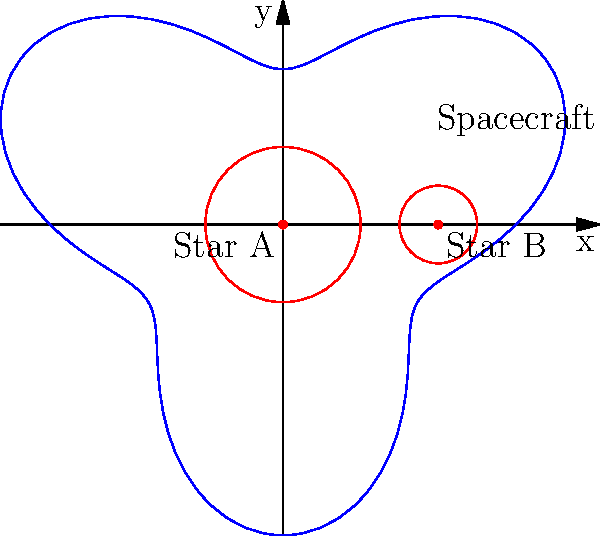In a binary star system, a spacecraft's orbit around the two stars can be described using polar coordinates. The orbit is given by the equation $r(\theta) = 3 + \sin(3\theta)$, where $r$ is in astronomical units (AU) and $\theta$ is in radians. What is the maximum distance the spacecraft reaches from the origin of the coordinate system? To find the maximum distance of the spacecraft from the origin, we need to follow these steps:

1) The distance $r$ is given by the equation $r(\theta) = 3 + \sin(3\theta)$.

2) The maximum value of $r$ will occur when $\sin(3\theta)$ reaches its maximum value.

3) We know that the maximum value of sine is 1, which occurs when its argument is $\frac{\pi}{2}$ or odd multiples of it.

4) So, we need to solve: $3\theta = \frac{\pi}{2}$ (or any odd multiple of $\frac{\pi}{2}$)

5) The solution doesn't matter for our purpose, as we just need the maximum value of $r$.

6) When $\sin(3\theta) = 1$, the equation becomes:

   $r_{max} = 3 + 1 = 4$

7) Therefore, the maximum distance the spacecraft reaches from the origin is 4 AU.

This orbit creates a fascinating three-lobed pattern around the binary star system, showcasing the complex gravitational interactions in such systems - a concept often explored in science fiction involving advanced space travel and exotic stellar environments.
Answer: 4 AU 